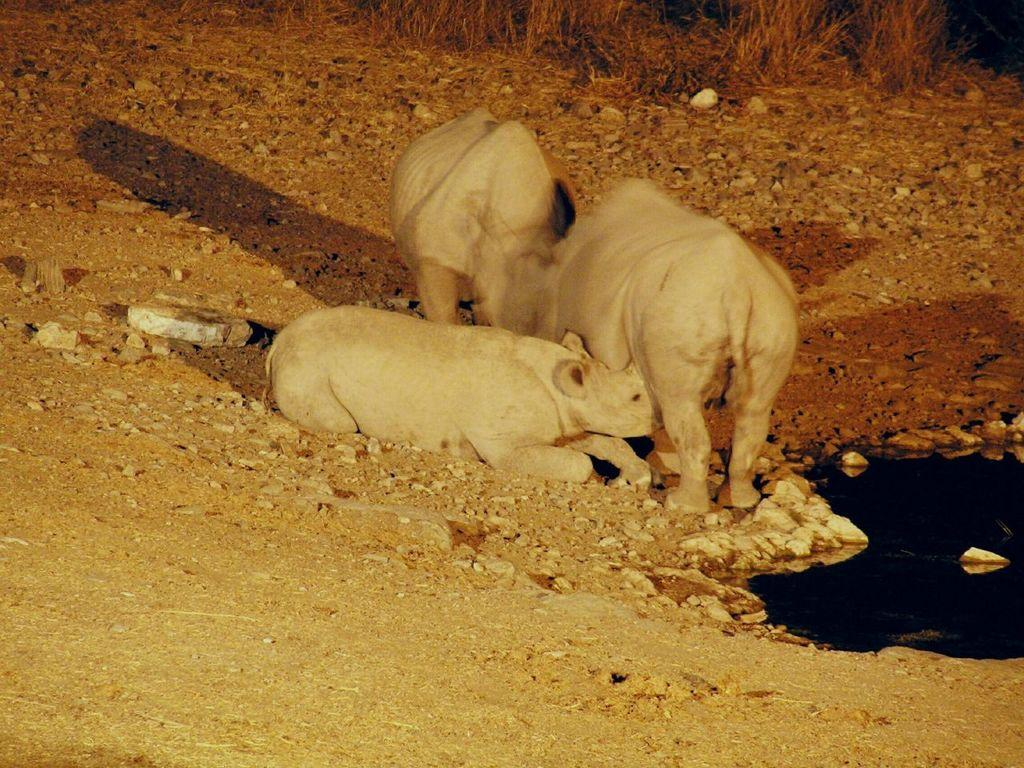What type of animals can be seen in the image? There are animals on the ground in the image. What is visible in the image besides the animals? Water is visible in the image. What type of vegetation can be seen in the background of the image? There is grass in the background of the image. Where is the cave located in the image? There is no cave present in the image. What type of camp can be seen in the image? There is no camp present in the image. 